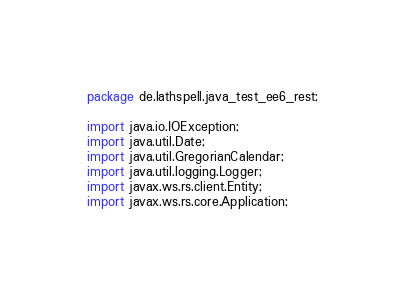Convert code to text. <code><loc_0><loc_0><loc_500><loc_500><_Java_>package de.lathspell.java_test_ee6_rest;

import java.io.IOException;
import java.util.Date;
import java.util.GregorianCalendar;
import java.util.logging.Logger;
import javax.ws.rs.client.Entity;
import javax.ws.rs.core.Application;</code> 